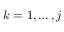<formula> <loc_0><loc_0><loc_500><loc_500>k = 1 , \dots c , j</formula> 